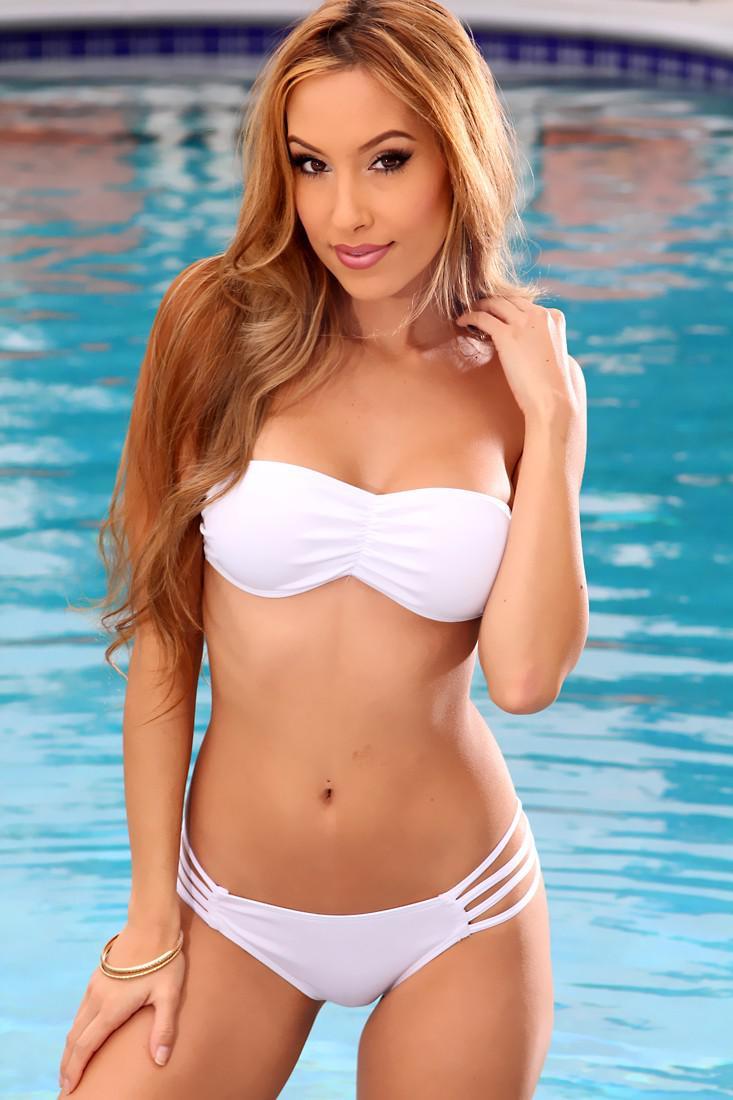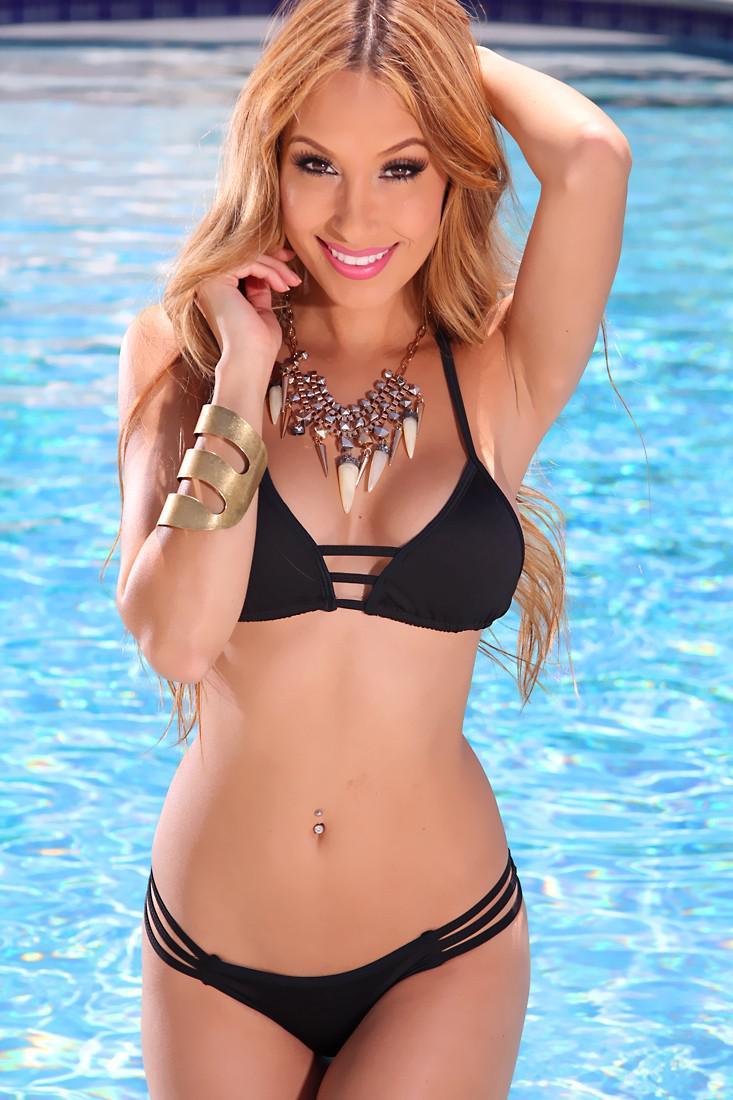The first image is the image on the left, the second image is the image on the right. Analyze the images presented: Is the assertion "At least one bikini is baby blue." valid? Answer yes or no. No. The first image is the image on the left, the second image is the image on the right. For the images displayed, is the sentence "The bikini in the image on the left is tied at the hip" factually correct? Answer yes or no. No. 